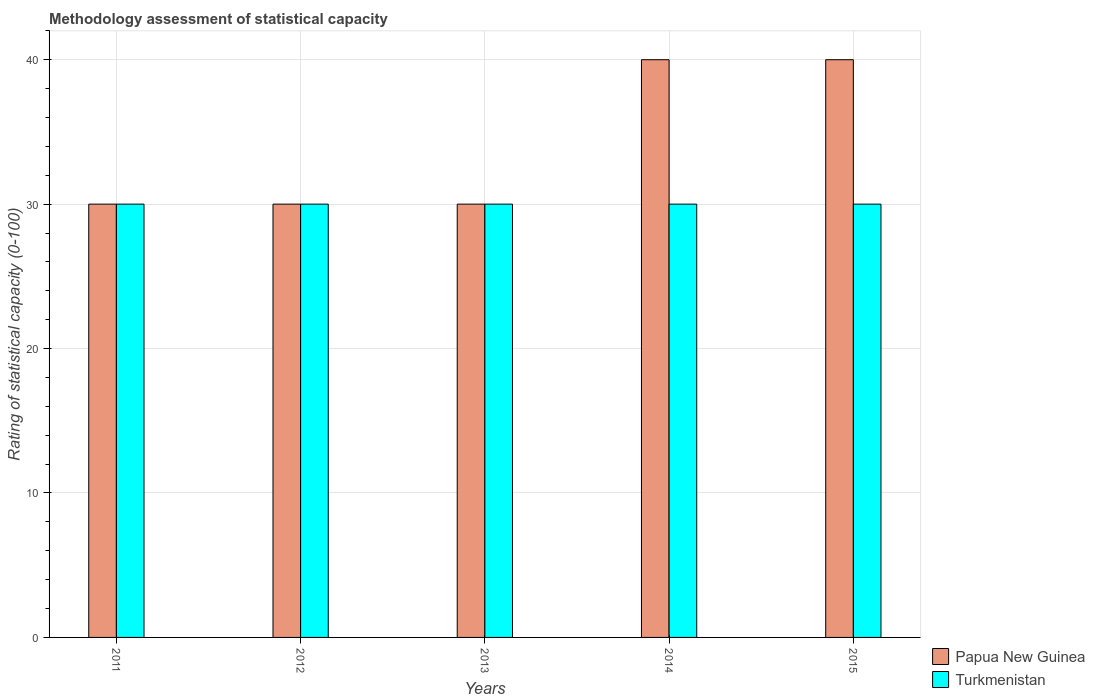How many different coloured bars are there?
Provide a short and direct response. 2. Are the number of bars per tick equal to the number of legend labels?
Provide a succinct answer. Yes. How many bars are there on the 3rd tick from the right?
Provide a short and direct response. 2. In how many cases, is the number of bars for a given year not equal to the number of legend labels?
Provide a succinct answer. 0. What is the rating of statistical capacity in Turkmenistan in 2013?
Keep it short and to the point. 30. Across all years, what is the maximum rating of statistical capacity in Papua New Guinea?
Provide a short and direct response. 40. Across all years, what is the minimum rating of statistical capacity in Papua New Guinea?
Give a very brief answer. 30. In which year was the rating of statistical capacity in Turkmenistan minimum?
Offer a terse response. 2011. What is the total rating of statistical capacity in Turkmenistan in the graph?
Give a very brief answer. 150. What is the difference between the rating of statistical capacity in Turkmenistan in 2011 and that in 2012?
Offer a terse response. 0. What is the difference between the rating of statistical capacity in Papua New Guinea in 2012 and the rating of statistical capacity in Turkmenistan in 2013?
Keep it short and to the point. 0. What is the average rating of statistical capacity in Papua New Guinea per year?
Ensure brevity in your answer.  34. In the year 2014, what is the difference between the rating of statistical capacity in Turkmenistan and rating of statistical capacity in Papua New Guinea?
Offer a very short reply. -10. Is the difference between the rating of statistical capacity in Turkmenistan in 2012 and 2014 greater than the difference between the rating of statistical capacity in Papua New Guinea in 2012 and 2014?
Provide a succinct answer. Yes. What is the difference between the highest and the lowest rating of statistical capacity in Turkmenistan?
Provide a succinct answer. 0. What does the 1st bar from the left in 2013 represents?
Ensure brevity in your answer.  Papua New Guinea. What does the 1st bar from the right in 2013 represents?
Offer a very short reply. Turkmenistan. How many bars are there?
Your answer should be very brief. 10. Does the graph contain any zero values?
Offer a very short reply. No. Does the graph contain grids?
Give a very brief answer. Yes. Where does the legend appear in the graph?
Your answer should be very brief. Bottom right. What is the title of the graph?
Make the answer very short. Methodology assessment of statistical capacity. What is the label or title of the Y-axis?
Your response must be concise. Rating of statistical capacity (0-100). What is the Rating of statistical capacity (0-100) in Papua New Guinea in 2011?
Offer a very short reply. 30. What is the Rating of statistical capacity (0-100) in Turkmenistan in 2011?
Offer a very short reply. 30. What is the Rating of statistical capacity (0-100) in Papua New Guinea in 2012?
Make the answer very short. 30. What is the Rating of statistical capacity (0-100) of Papua New Guinea in 2013?
Keep it short and to the point. 30. What is the Rating of statistical capacity (0-100) in Papua New Guinea in 2014?
Offer a very short reply. 40. Across all years, what is the maximum Rating of statistical capacity (0-100) of Papua New Guinea?
Your answer should be very brief. 40. Across all years, what is the maximum Rating of statistical capacity (0-100) in Turkmenistan?
Keep it short and to the point. 30. Across all years, what is the minimum Rating of statistical capacity (0-100) in Papua New Guinea?
Make the answer very short. 30. What is the total Rating of statistical capacity (0-100) of Papua New Guinea in the graph?
Keep it short and to the point. 170. What is the total Rating of statistical capacity (0-100) in Turkmenistan in the graph?
Give a very brief answer. 150. What is the difference between the Rating of statistical capacity (0-100) of Papua New Guinea in 2011 and that in 2014?
Make the answer very short. -10. What is the difference between the Rating of statistical capacity (0-100) of Turkmenistan in 2011 and that in 2014?
Make the answer very short. 0. What is the difference between the Rating of statistical capacity (0-100) in Papua New Guinea in 2011 and that in 2015?
Keep it short and to the point. -10. What is the difference between the Rating of statistical capacity (0-100) in Turkmenistan in 2011 and that in 2015?
Offer a very short reply. 0. What is the difference between the Rating of statistical capacity (0-100) of Papua New Guinea in 2012 and that in 2013?
Make the answer very short. 0. What is the difference between the Rating of statistical capacity (0-100) of Papua New Guinea in 2012 and that in 2014?
Provide a short and direct response. -10. What is the difference between the Rating of statistical capacity (0-100) of Papua New Guinea in 2012 and that in 2015?
Make the answer very short. -10. What is the difference between the Rating of statistical capacity (0-100) in Papua New Guinea in 2013 and that in 2014?
Provide a short and direct response. -10. What is the difference between the Rating of statistical capacity (0-100) of Papua New Guinea in 2013 and that in 2015?
Offer a terse response. -10. What is the difference between the Rating of statistical capacity (0-100) of Turkmenistan in 2013 and that in 2015?
Provide a succinct answer. 0. What is the difference between the Rating of statistical capacity (0-100) of Turkmenistan in 2014 and that in 2015?
Offer a terse response. 0. What is the difference between the Rating of statistical capacity (0-100) of Papua New Guinea in 2011 and the Rating of statistical capacity (0-100) of Turkmenistan in 2012?
Offer a terse response. 0. What is the difference between the Rating of statistical capacity (0-100) in Papua New Guinea in 2011 and the Rating of statistical capacity (0-100) in Turkmenistan in 2014?
Give a very brief answer. 0. What is the difference between the Rating of statistical capacity (0-100) of Papua New Guinea in 2011 and the Rating of statistical capacity (0-100) of Turkmenistan in 2015?
Ensure brevity in your answer.  0. What is the difference between the Rating of statistical capacity (0-100) of Papua New Guinea in 2012 and the Rating of statistical capacity (0-100) of Turkmenistan in 2014?
Your answer should be very brief. 0. What is the difference between the Rating of statistical capacity (0-100) in Papua New Guinea in 2013 and the Rating of statistical capacity (0-100) in Turkmenistan in 2014?
Offer a very short reply. 0. What is the difference between the Rating of statistical capacity (0-100) of Papua New Guinea in 2013 and the Rating of statistical capacity (0-100) of Turkmenistan in 2015?
Give a very brief answer. 0. What is the difference between the Rating of statistical capacity (0-100) of Papua New Guinea in 2014 and the Rating of statistical capacity (0-100) of Turkmenistan in 2015?
Give a very brief answer. 10. What is the average Rating of statistical capacity (0-100) of Turkmenistan per year?
Provide a succinct answer. 30. In the year 2011, what is the difference between the Rating of statistical capacity (0-100) in Papua New Guinea and Rating of statistical capacity (0-100) in Turkmenistan?
Ensure brevity in your answer.  0. In the year 2015, what is the difference between the Rating of statistical capacity (0-100) of Papua New Guinea and Rating of statistical capacity (0-100) of Turkmenistan?
Make the answer very short. 10. What is the ratio of the Rating of statistical capacity (0-100) of Papua New Guinea in 2011 to that in 2012?
Provide a succinct answer. 1. What is the ratio of the Rating of statistical capacity (0-100) in Turkmenistan in 2011 to that in 2012?
Offer a terse response. 1. What is the ratio of the Rating of statistical capacity (0-100) of Turkmenistan in 2011 to that in 2013?
Provide a succinct answer. 1. What is the ratio of the Rating of statistical capacity (0-100) of Papua New Guinea in 2011 to that in 2014?
Your answer should be compact. 0.75. What is the ratio of the Rating of statistical capacity (0-100) of Papua New Guinea in 2012 to that in 2013?
Offer a very short reply. 1. What is the ratio of the Rating of statistical capacity (0-100) of Turkmenistan in 2012 to that in 2014?
Give a very brief answer. 1. What is the ratio of the Rating of statistical capacity (0-100) of Turkmenistan in 2012 to that in 2015?
Provide a short and direct response. 1. What is the ratio of the Rating of statistical capacity (0-100) in Papua New Guinea in 2013 to that in 2015?
Ensure brevity in your answer.  0.75. What is the ratio of the Rating of statistical capacity (0-100) in Turkmenistan in 2013 to that in 2015?
Give a very brief answer. 1. What is the difference between the highest and the second highest Rating of statistical capacity (0-100) in Papua New Guinea?
Ensure brevity in your answer.  0. What is the difference between the highest and the lowest Rating of statistical capacity (0-100) of Papua New Guinea?
Make the answer very short. 10. 